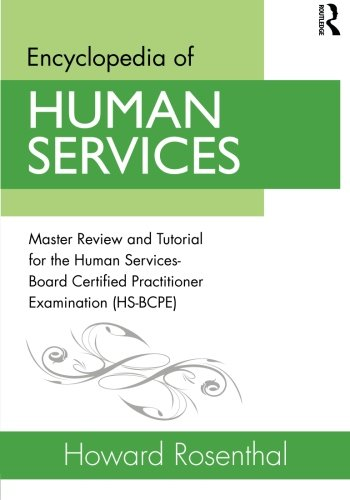Is this book related to Science & Math? No, this book is not related to the Science & Math categories. It is firmly rooted in the human services field, which is primarily linked to social sciences rather than natural sciences or mathematics. 